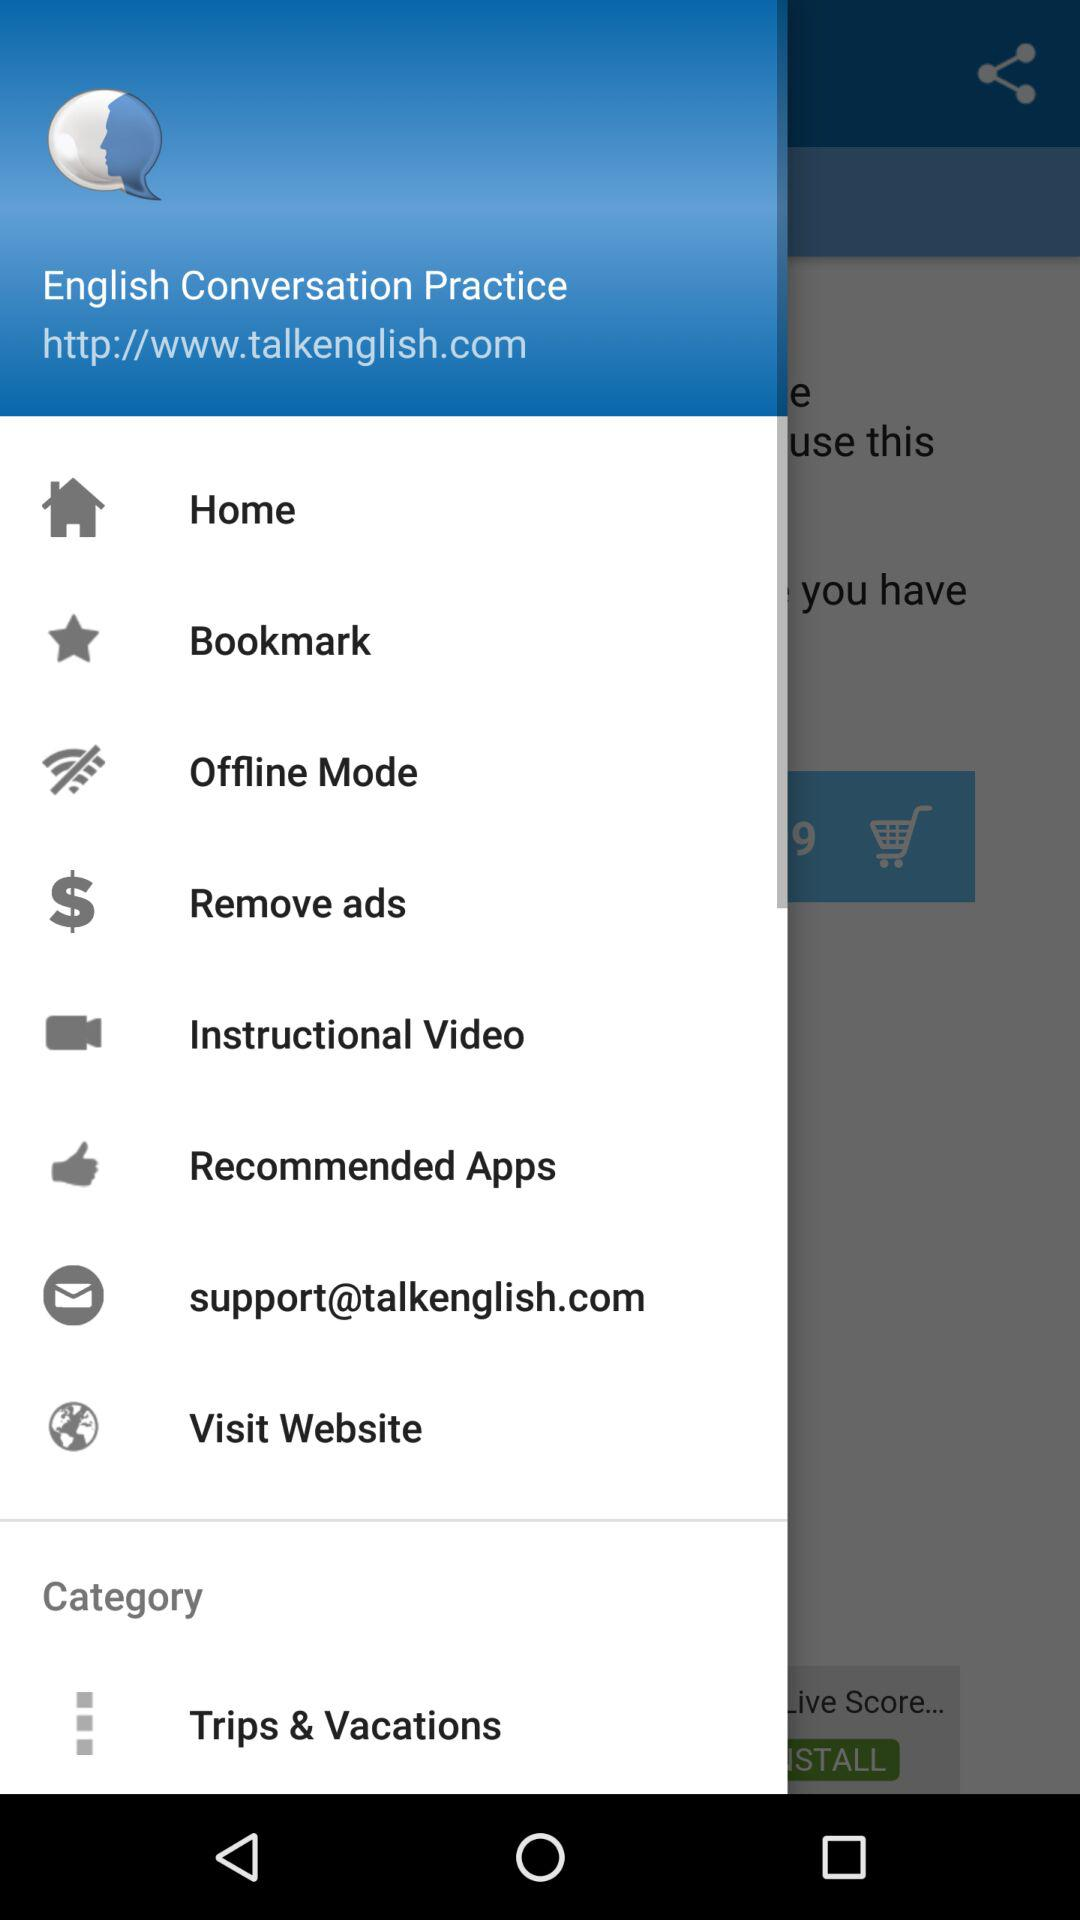How many notifications are there in "Bookmark"?
When the provided information is insufficient, respond with <no answer>. <no answer> 